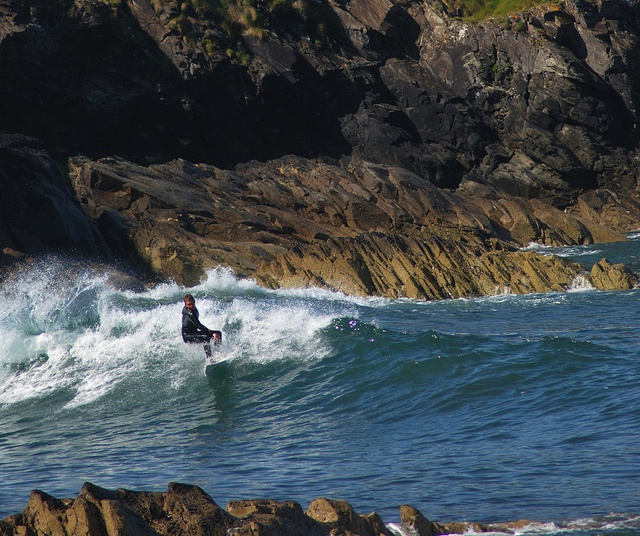Describe the objects in this image and their specific colors. I can see people in black, gray, navy, and darkgray tones and surfboard in black, blue, darkgray, and lightgray tones in this image. 